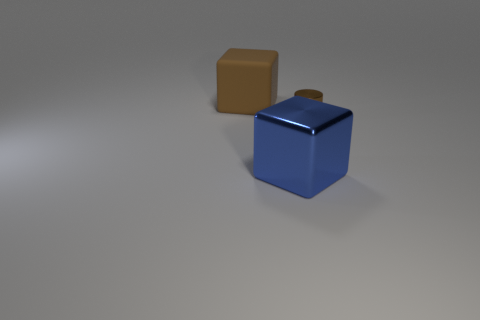Add 3 large blue objects. How many objects exist? 6 Subtract all cylinders. How many objects are left? 2 Add 1 big blue things. How many big blue things exist? 2 Subtract 0 green cubes. How many objects are left? 3 Subtract all brown objects. Subtract all purple metallic cylinders. How many objects are left? 1 Add 2 brown metallic objects. How many brown metallic objects are left? 3 